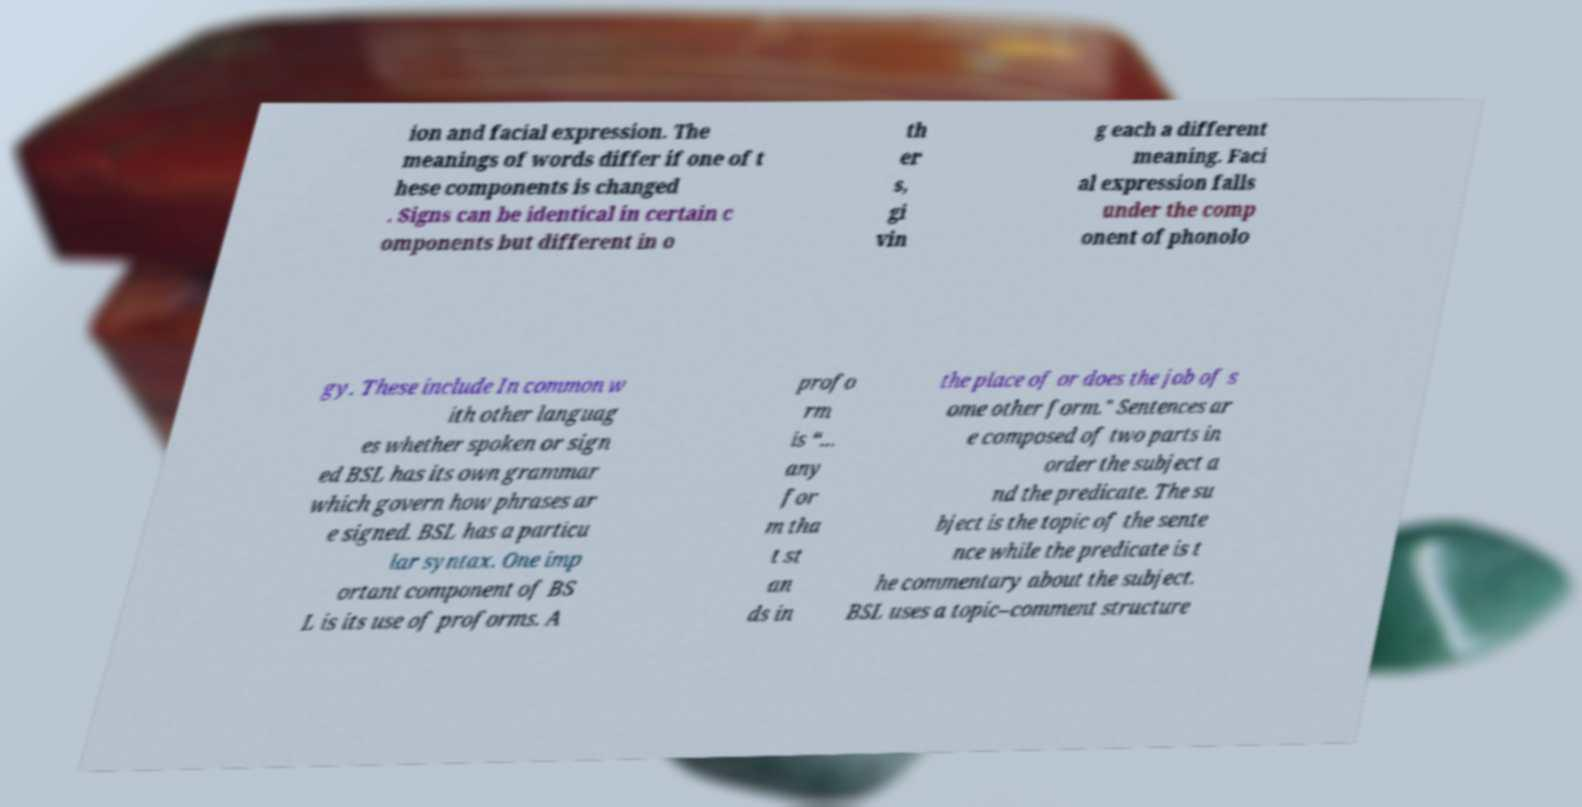Please identify and transcribe the text found in this image. ion and facial expression. The meanings of words differ if one of t hese components is changed . Signs can be identical in certain c omponents but different in o th er s, gi vin g each a different meaning. Faci al expression falls under the comp onent of phonolo gy. These include In common w ith other languag es whether spoken or sign ed BSL has its own grammar which govern how phrases ar e signed. BSL has a particu lar syntax. One imp ortant component of BS L is its use of proforms. A profo rm is “... any for m tha t st an ds in the place of or does the job of s ome other form." Sentences ar e composed of two parts in order the subject a nd the predicate. The su bject is the topic of the sente nce while the predicate is t he commentary about the subject. BSL uses a topic–comment structure 